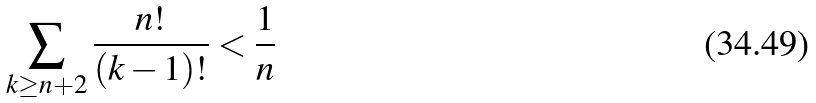Convert formula to latex. <formula><loc_0><loc_0><loc_500><loc_500>\sum _ { k \geq n + 2 } \frac { n ! } { ( k - 1 ) ! } < \frac { 1 } { n }</formula> 